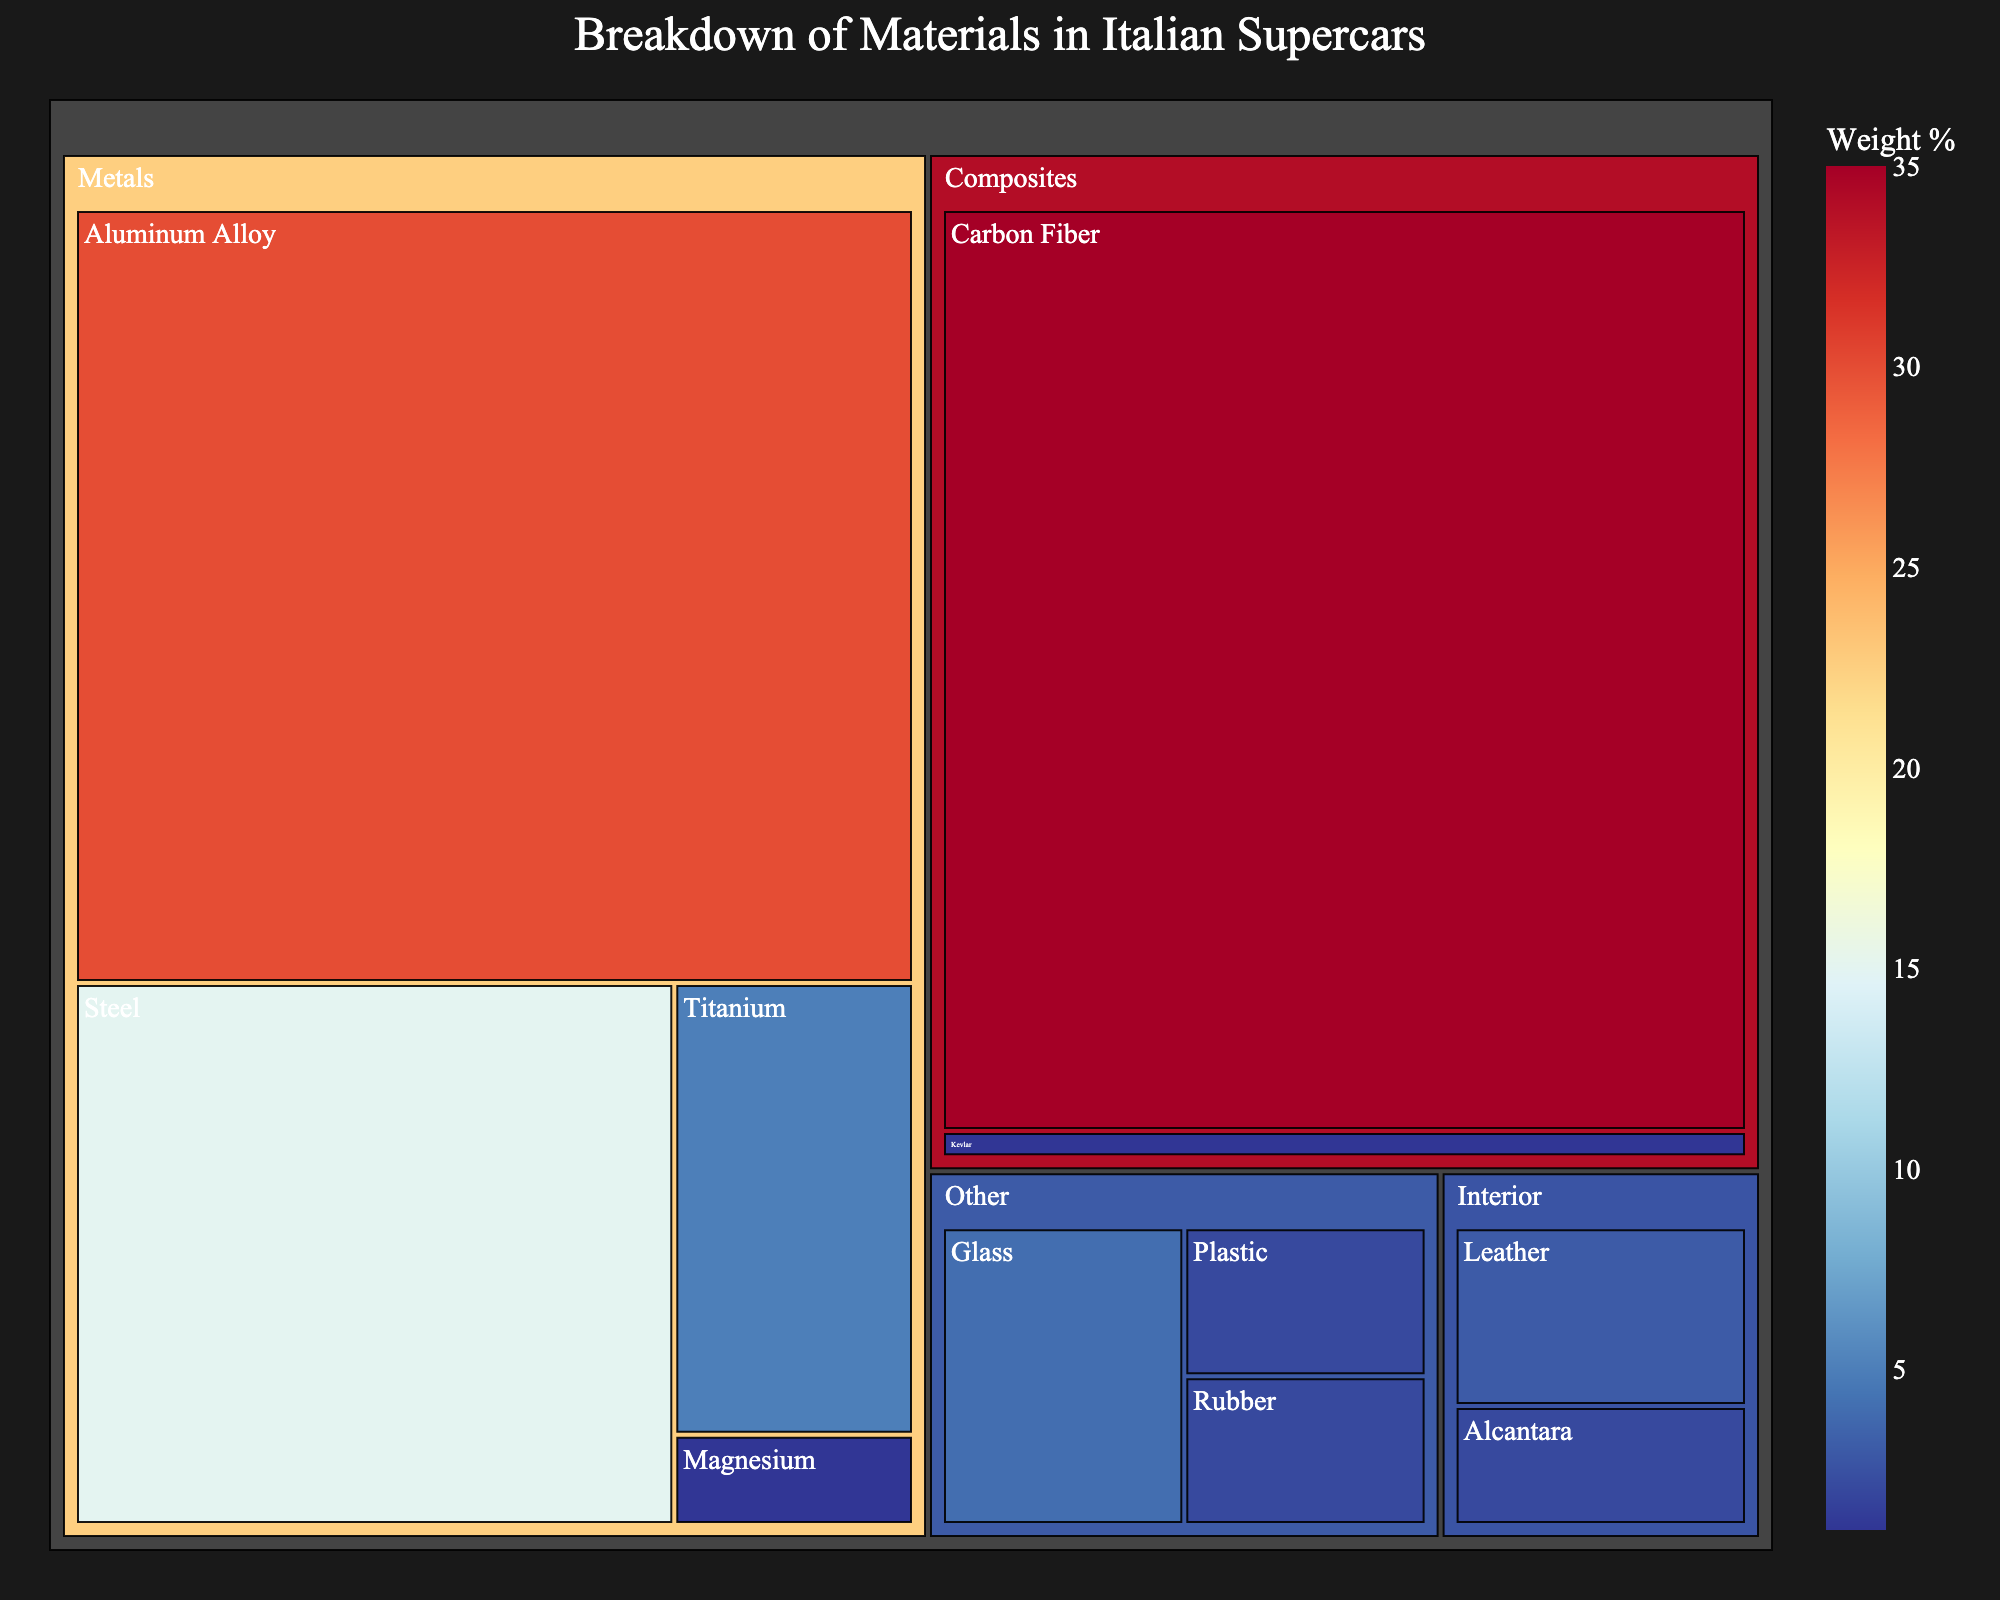What material has the highest weight percentage in the construction of Italian supercars? The biggest rectangle in a treemap typically represents the largest value. The largest category in this treemap is Carbon Fiber, which is under the Composites category.
Answer: Carbon Fiber Which category contains the most materials? By looking at the number of smaller rectangles within each larger category, it can be seen that the Metals category contains the most materials with four (Aluminum Alloy, Steel, Titanium, and Magnesium).
Answer: Metals What is the combined weight percentage of metals used in Italian supercar construction? Sum the weight percentages of all materials in the Metals category: Aluminum Alloy (30%) + Steel (15%) + Titanium (5%) + Magnesium (1%). The combined weight percentage is 30% + 15% + 5% + 1% = 51%.
Answer: 51% In which category is Leather found? By looking at the category labels in the treemap, Leather is located within the Interior category.
Answer: Interior How does the weight percentage of Kevlar compare to Alcantara? Kevlar has a weight percentage of 1%, and Alcantara has a weight percentage of 2%. Alcantara's weight percentage is greater than Kevlar's.
Answer: Alcantara is greater What are the percentages of the two materials in the Other category with the smallest weight percentages? The Other category includes Glass, Rubber, and Plastic. Rubber and Plastic have the smallest weight percentages in the Other category at 2% each.
Answer: 2% and 2% What is the percentage difference between Carbon Fiber and Aluminum Alloy? Subtract the weight percentage of Aluminum Alloy (30%) from that of Carbon Fiber (35%): 35% - 30% = 5%.
Answer: 5% Which material has the lowest weight percentage in Italian supercar construction, and what is its percentage? The smallest rectangle usually represents the smallest value. Kevlar is the material with the lowest weight percentage at 1%.
Answer: Kevlar, 1% How many different materials are listed in the treemap? Count all distinct materials mentioned: Carbon Fiber, Aluminum Alloy, Steel, Titanium, Glass, Leather, Alcantara, Rubber, Plastic, Kevlar, and Magnesium. That yields 11 different materials.
Answer: 11 materials Which material category is responsible for less than 10% of the weight, and what are the materials under this category? By summing up the weight percentages and comparing them: Other has a total of 8% (4% Glass + 2% Rubber + 2% Plastic) which is less than 10%. Materials under this category are Glass, Rubber, and Plastic.
Answer: Other; Glass, Rubber, Plastic 